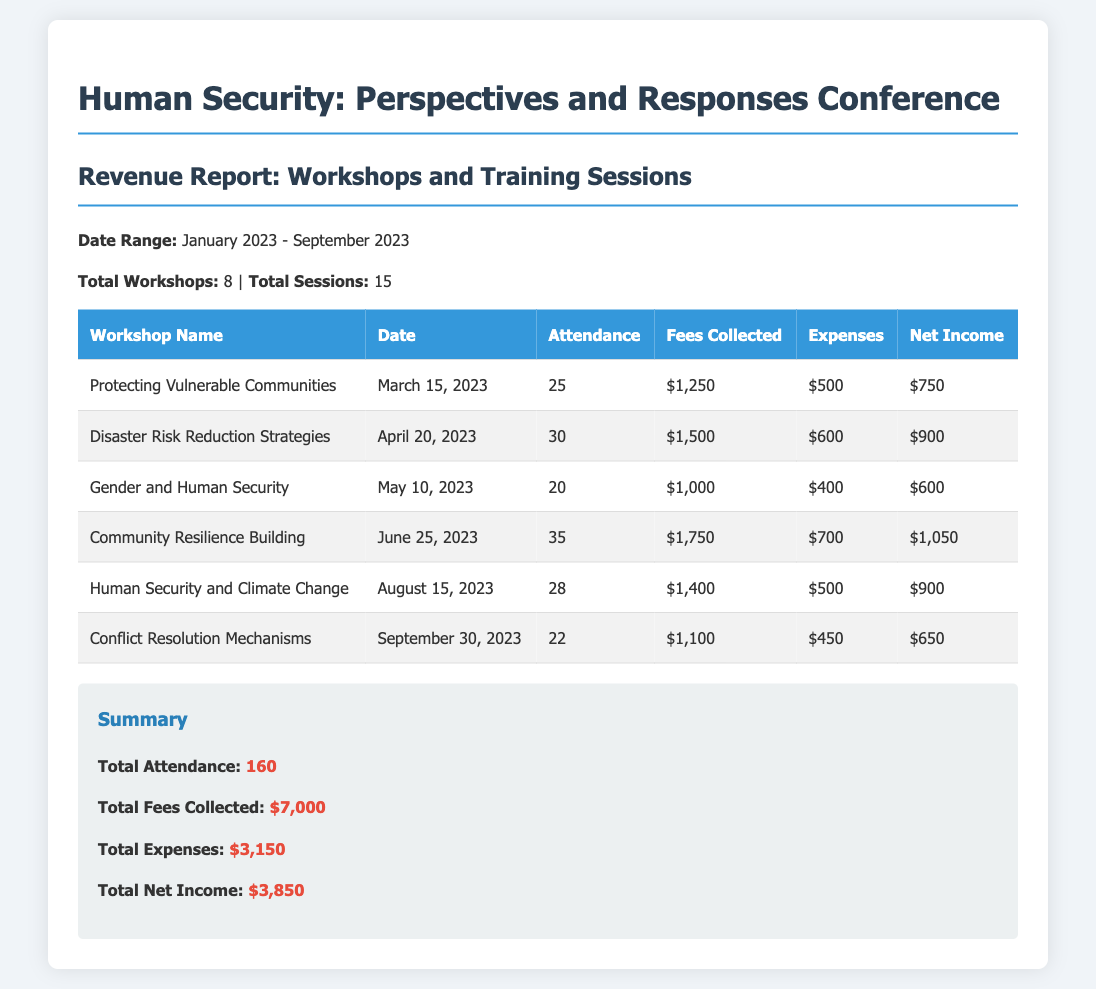What is the date range for the revenue report? The date range is mentioned at the beginning of the document, covering January 2023 to September 2023.
Answer: January 2023 - September 2023 How many total workshops were held? The total number of workshops is specified in the summary section of the document.
Answer: 8 What is the net income from the workshop "Community Resilience Building"? The net income is listed in the table for each workshop, specifically for "Community Resilience Building."
Answer: $1,050 What was the attendance for the workshop "Disaster Risk Reduction Strategies"? The attendance figure is provided in the attendance column of the table for the specific workshop.
Answer: 30 What is the total fees collected from all workshops? The total fees collected is a summarized figure calculated from all individual fees listed in the document.
Answer: $7,000 Which workshop had the highest net income? The highest net income can be discerned by comparing the net income values in the table for each workshop.
Answer: Protecting Vulnerable Communities What is the total number of sessions conducted? The total number of sessions is summarized at the top of the document, indicating how many sessions took place.
Answer: 15 What were the total expenses across all workshops? The total expenses figure is provided in the summary section, aggregating all individual expenses from each workshop.
Answer: $3,150 